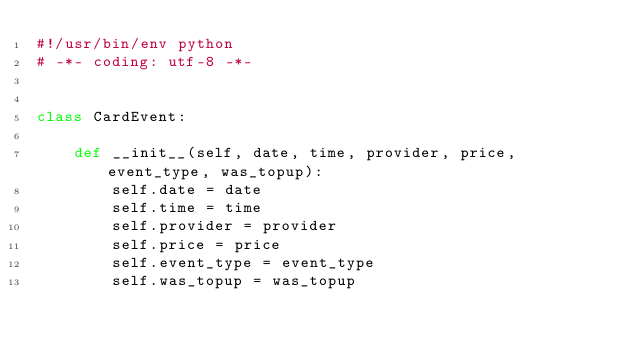Convert code to text. <code><loc_0><loc_0><loc_500><loc_500><_Python_>#!/usr/bin/env python
# -*- coding: utf-8 -*-


class CardEvent:

    def __init__(self, date, time, provider, price, event_type, was_topup):
        self.date = date
        self.time = time
        self.provider = provider
        self.price = price
        self.event_type = event_type
        self.was_topup = was_topup
</code> 